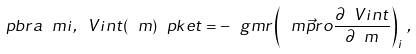Convert formula to latex. <formula><loc_0><loc_0><loc_500><loc_500>\ p b r a \ m i , \ V i n t ( \ m ) \ p k e t = - \ g m r \left ( \ m \vec { p } r o \frac { \partial \ V i n t } { \partial \ m } \right ) _ { i } \, ,</formula> 